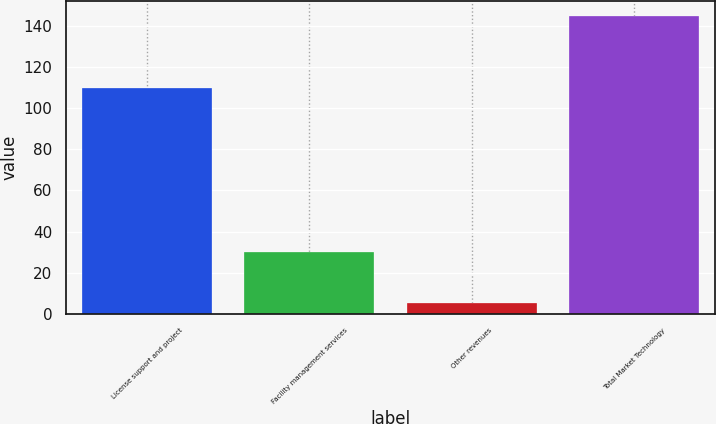Convert chart to OTSL. <chart><loc_0><loc_0><loc_500><loc_500><bar_chart><fcel>License support and project<fcel>Facility management services<fcel>Other revenues<fcel>Total Market Technology<nl><fcel>110<fcel>30<fcel>5<fcel>145<nl></chart> 